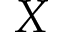<formula> <loc_0><loc_0><loc_500><loc_500>X</formula> 